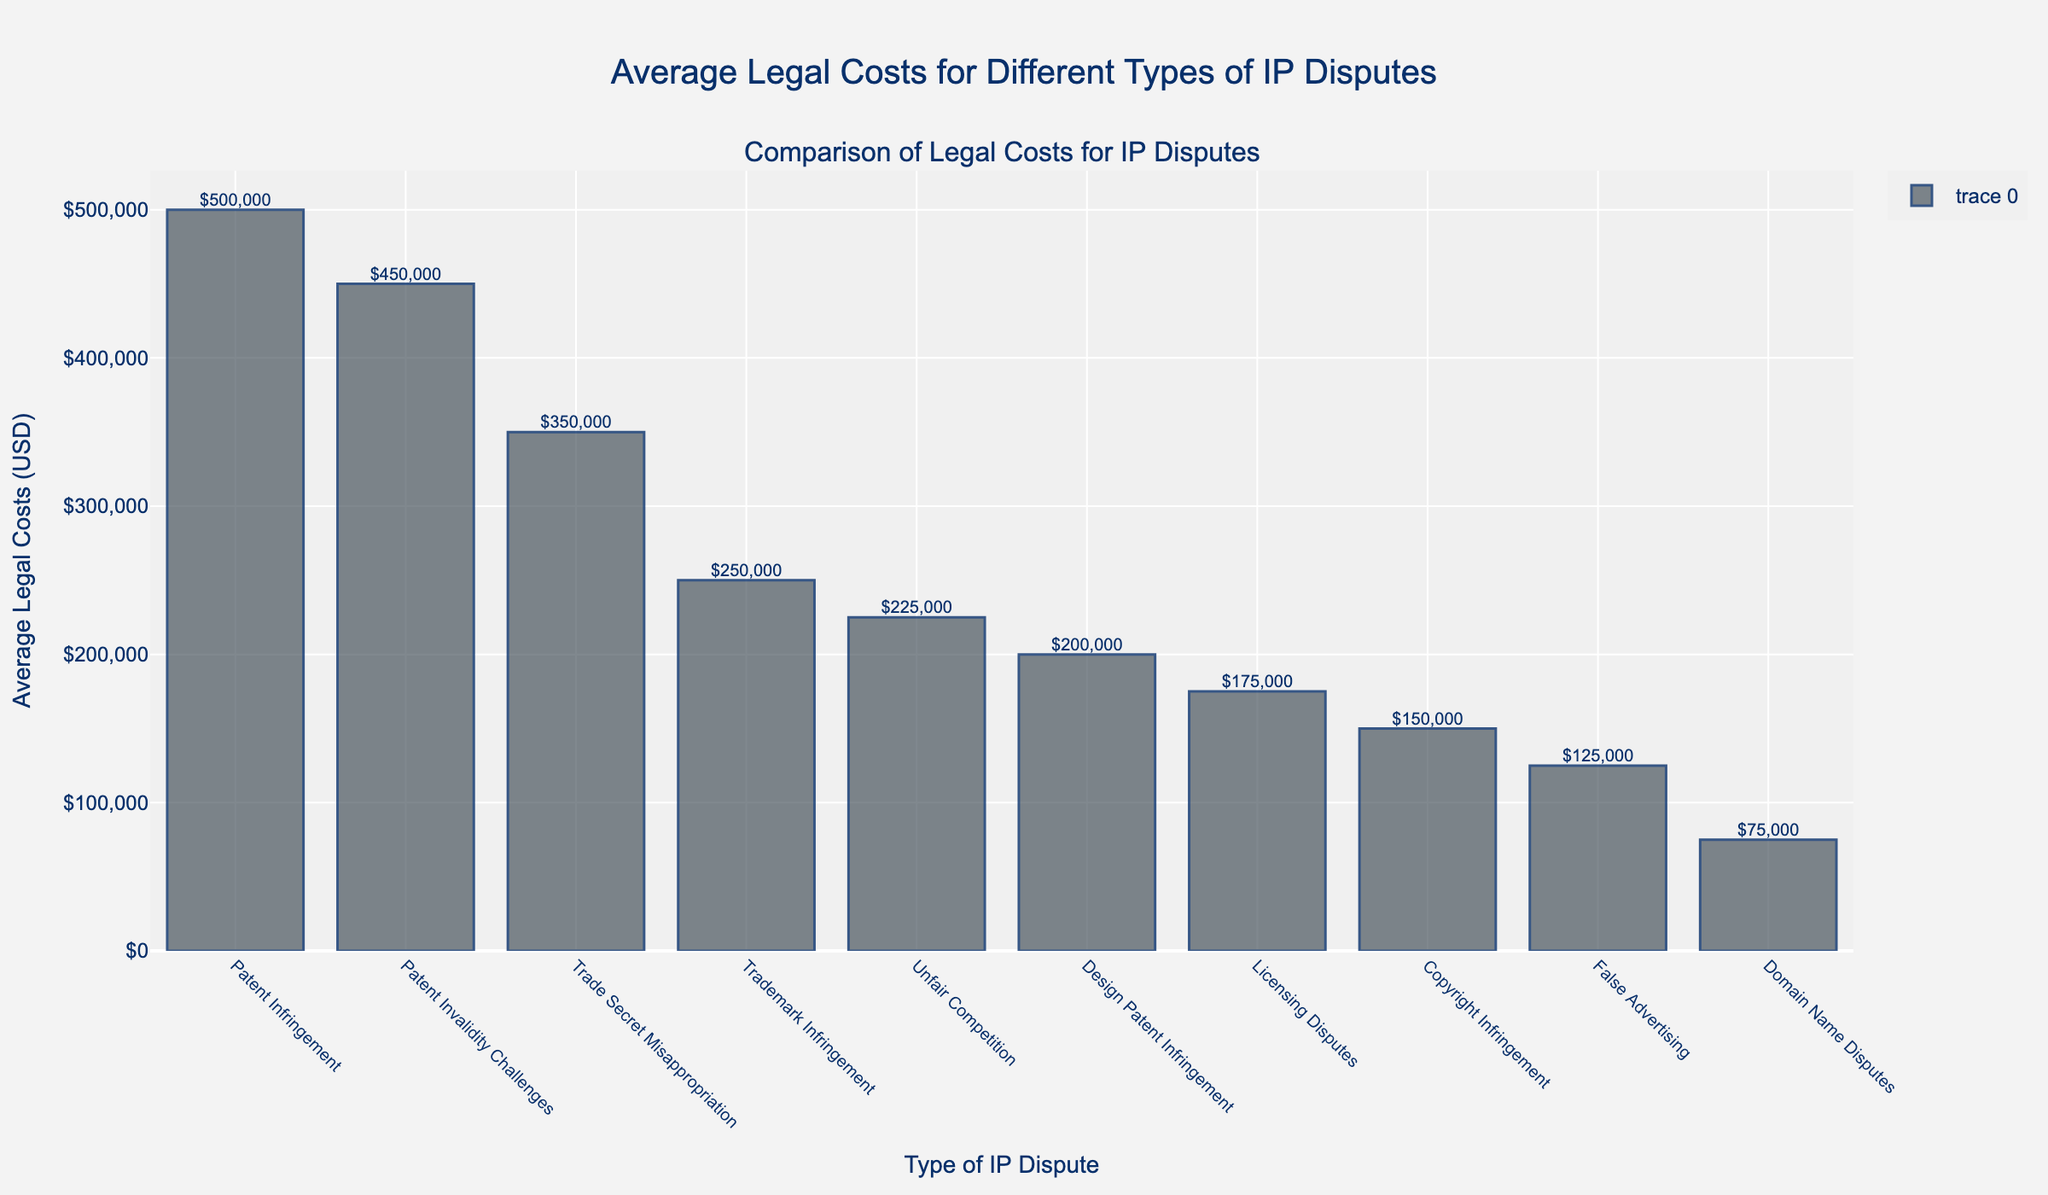Which type of IP dispute incurs the highest average legal cost? The bar representing "Patent Infringement" is the tallest, indicating it has the highest average legal cost.
Answer: Patent Infringement What is the average legal cost for Trademark Infringement? Refer to the bar labeled "Trademark Infringement" and the value shown on top of the bar, which is $250,000.
Answer: $250,000 How much more expensive is handling a Patent Infringement case compared to a Copyright Infringement case? Identify the bars for "Patent Infringement" ($500,000) and "Copyright Infringement" ($150,000), then subtract the latter from the former: $500,000 - $150,000 = $350,000.
Answer: $350,000 Which type of dispute has the lowest average legal cost? The shortest bar corresponds to "Domain Name Disputes" with an average legal cost of $75,000.
Answer: Domain Name Disputes What is the difference in legal costs between Trade Secret Misappropriation and Unfair Competition? Find the bars for "Trade Secret Misappropriation" ($350,000) and "Unfair Competition" ($225,000), then calculate the difference: $350,000 - $225,000 = $125,000.
Answer: $125,000 Rank the types of disputes from the highest to the lowest in terms of average legal costs. Order the heights of the bars from tallest to shortest: (1) Patent Infringement, (2) Patent Invalidity Challenges, (3) Trade Secret Misappropriation, (4) Trademark Infringement, (5) Unfair Competition, (6) Design Patent Infringement, (7) Licensing Disputes, (8) Copyright Infringement, (9) False Advertising, (10) Domain Name Disputes.
Answer: Patent Infringement, Patent Invalidity Challenges, Trade Secret Misappropriation, Trademark Infringement, Unfair Competition, Design Patent Infringement, Licensing Disputes, Copyright Infringement, False Advertising, Domain Name Disputes Calculate the total average legal costs for dealing with all listed IP disputes. Add the values of all bars: $500,000 + $250,000 + $150,000 + $350,000 + $200,000 + $175,000 + $75,000 + $125,000 + $225,000 + $450,000 = $2,500,000.
Answer: $2,500,000 What can be inferred about the relative cost-effectiveness of managing Domain Name Disputes as compared to Trade Secret Misappropriation? The bar for "Domain Name Disputes" is much shorter than the bar for "Trade Secret Misappropriation", indicating that Domain Name Disputes incur significantly lower average legal costs.
Answer: Domain Name Disputes are more cost-effective 